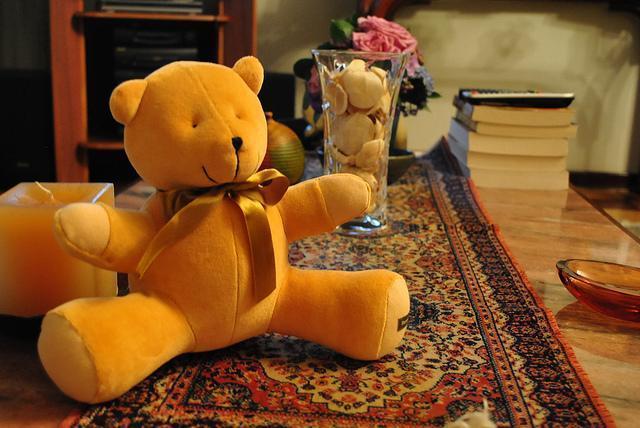Verify the accuracy of this image caption: "The dining table is in front of the teddy bear.".
Answer yes or no. No. Evaluate: Does the caption "The dining table is at the left side of the teddy bear." match the image?
Answer yes or no. No. Is the statement "The teddy bear is connected to the dining table." accurate regarding the image?
Answer yes or no. Yes. 